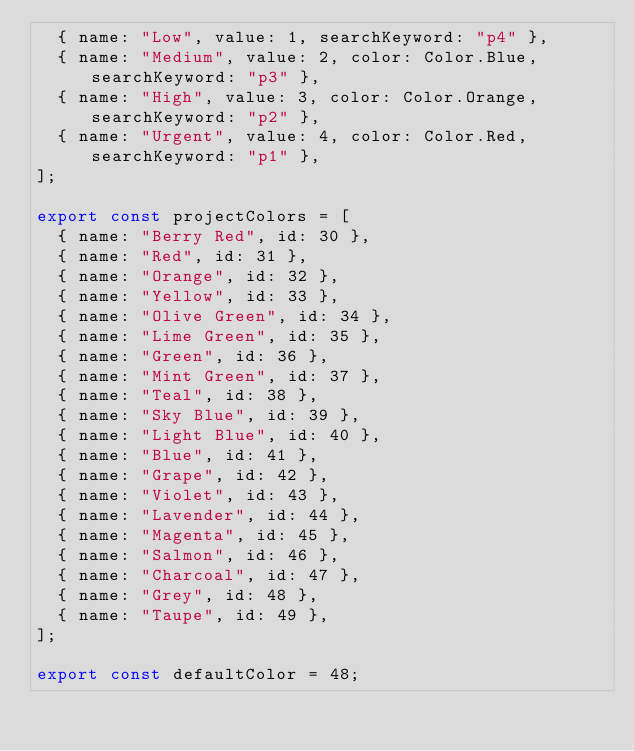<code> <loc_0><loc_0><loc_500><loc_500><_TypeScript_>  { name: "Low", value: 1, searchKeyword: "p4" },
  { name: "Medium", value: 2, color: Color.Blue, searchKeyword: "p3" },
  { name: "High", value: 3, color: Color.Orange, searchKeyword: "p2" },
  { name: "Urgent", value: 4, color: Color.Red, searchKeyword: "p1" },
];

export const projectColors = [
  { name: "Berry Red", id: 30 },
  { name: "Red", id: 31 },
  { name: "Orange", id: 32 },
  { name: "Yellow", id: 33 },
  { name: "Olive Green", id: 34 },
  { name: "Lime Green", id: 35 },
  { name: "Green", id: 36 },
  { name: "Mint Green", id: 37 },
  { name: "Teal", id: 38 },
  { name: "Sky Blue", id: 39 },
  { name: "Light Blue", id: 40 },
  { name: "Blue", id: 41 },
  { name: "Grape", id: 42 },
  { name: "Violet", id: 43 },
  { name: "Lavender", id: 44 },
  { name: "Magenta", id: 45 },
  { name: "Salmon", id: 46 },
  { name: "Charcoal", id: 47 },
  { name: "Grey", id: 48 },
  { name: "Taupe", id: 49 },
];

export const defaultColor = 48;
</code> 